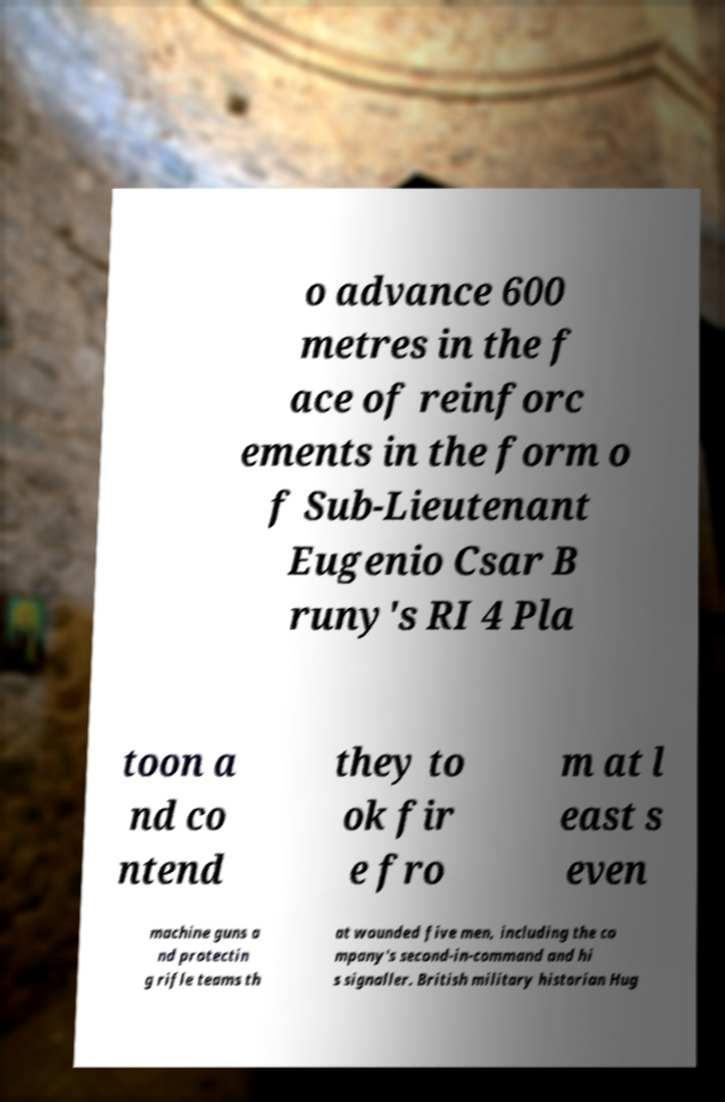Could you extract and type out the text from this image? o advance 600 metres in the f ace of reinforc ements in the form o f Sub-Lieutenant Eugenio Csar B runy's RI 4 Pla toon a nd co ntend they to ok fir e fro m at l east s even machine guns a nd protectin g rifle teams th at wounded five men, including the co mpany's second-in-command and hi s signaller. British military historian Hug 